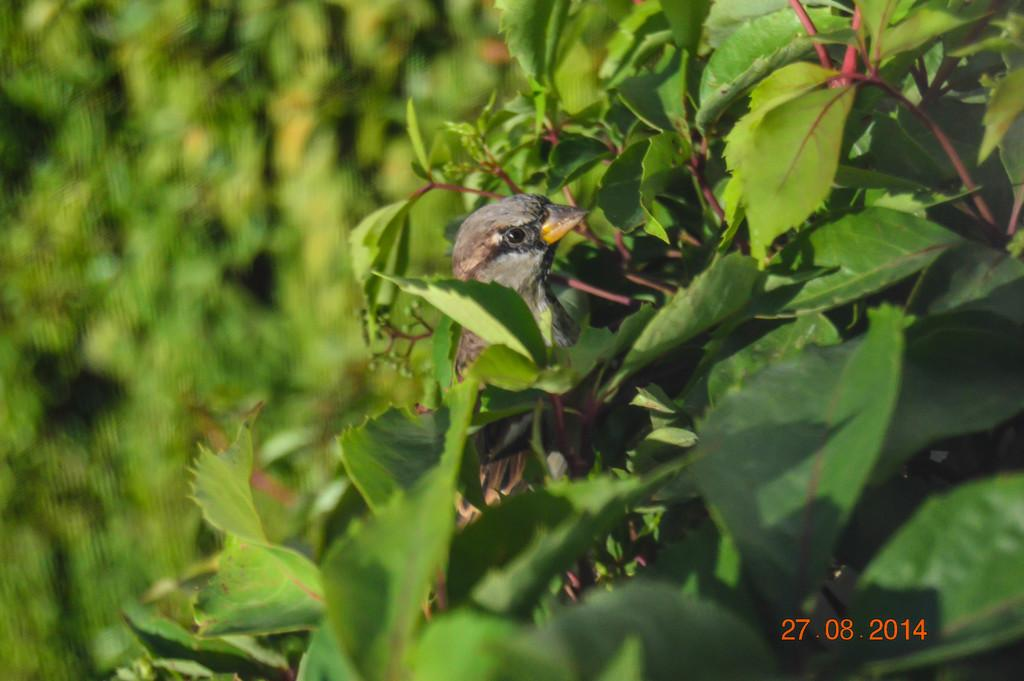What type of animal is present in the image? There is a bird in the image. What other objects or elements can be seen in the image? There are leaves in the image. Can you describe the background of the image? The background of the image is blurry. What color is the orange in the image? There is no orange present in the image. How many forks can be seen in the image? There are no forks present in the image. 